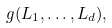Convert formula to latex. <formula><loc_0><loc_0><loc_500><loc_500>g ( L _ { 1 } , \dots , L _ { d } ) ,</formula> 